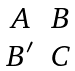<formula> <loc_0><loc_0><loc_500><loc_500>\begin{matrix} A & B \\ B ^ { \prime } & C \end{matrix}</formula> 